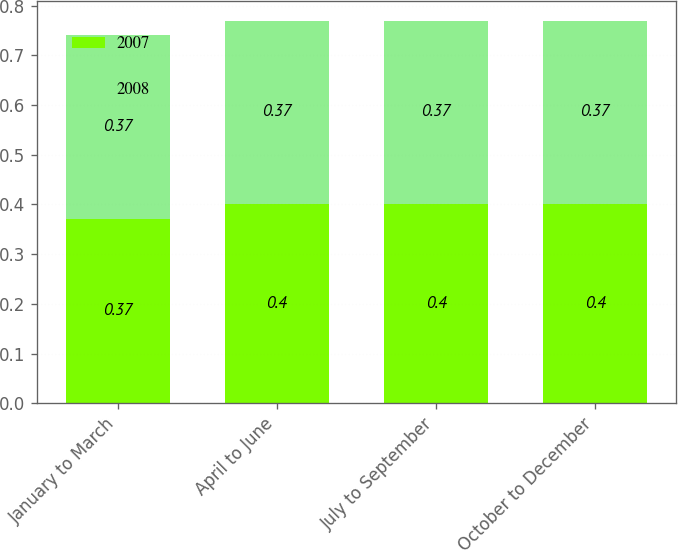Convert chart to OTSL. <chart><loc_0><loc_0><loc_500><loc_500><stacked_bar_chart><ecel><fcel>January to March<fcel>April to June<fcel>July to September<fcel>October to December<nl><fcel>2007<fcel>0.37<fcel>0.4<fcel>0.4<fcel>0.4<nl><fcel>2008<fcel>0.37<fcel>0.37<fcel>0.37<fcel>0.37<nl></chart> 